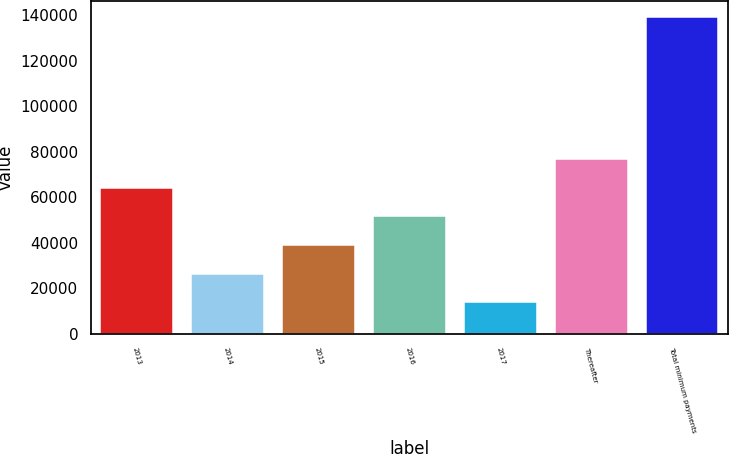<chart> <loc_0><loc_0><loc_500><loc_500><bar_chart><fcel>2013<fcel>2014<fcel>2015<fcel>2016<fcel>2017<fcel>Thereafter<fcel>Total minimum payments<nl><fcel>64046.6<fcel>26390.9<fcel>38942.8<fcel>51494.7<fcel>13839<fcel>76598.5<fcel>139358<nl></chart> 